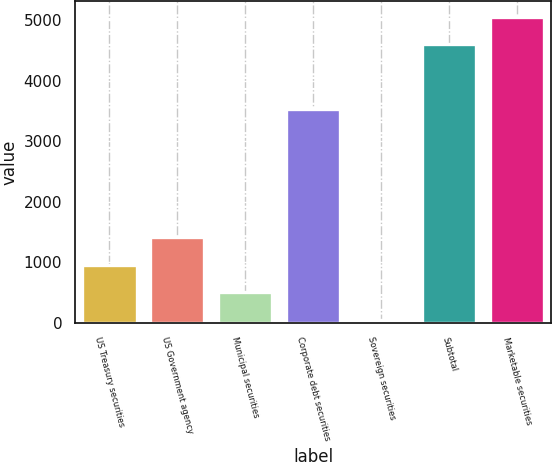<chart> <loc_0><loc_0><loc_500><loc_500><bar_chart><fcel>US Treasury securities<fcel>US Government agency<fcel>Municipal securities<fcel>Corporate debt securities<fcel>Sovereign securities<fcel>Subtotal<fcel>Marketable securities<nl><fcel>957.4<fcel>1413.1<fcel>501.7<fcel>3526<fcel>46<fcel>4603<fcel>5058.7<nl></chart> 